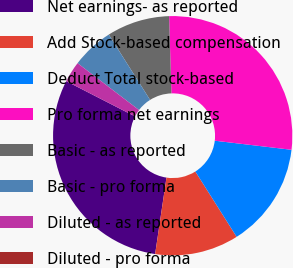Convert chart to OTSL. <chart><loc_0><loc_0><loc_500><loc_500><pie_chart><fcel>Net earnings- as reported<fcel>Add Stock-based compensation<fcel>Deduct Total stock-based<fcel>Pro forma net earnings<fcel>Basic - as reported<fcel>Basic - pro forma<fcel>Diluted - as reported<fcel>Diluted - pro forma<nl><fcel>30.19%<fcel>11.32%<fcel>14.15%<fcel>27.36%<fcel>8.49%<fcel>5.66%<fcel>2.83%<fcel>0.0%<nl></chart> 